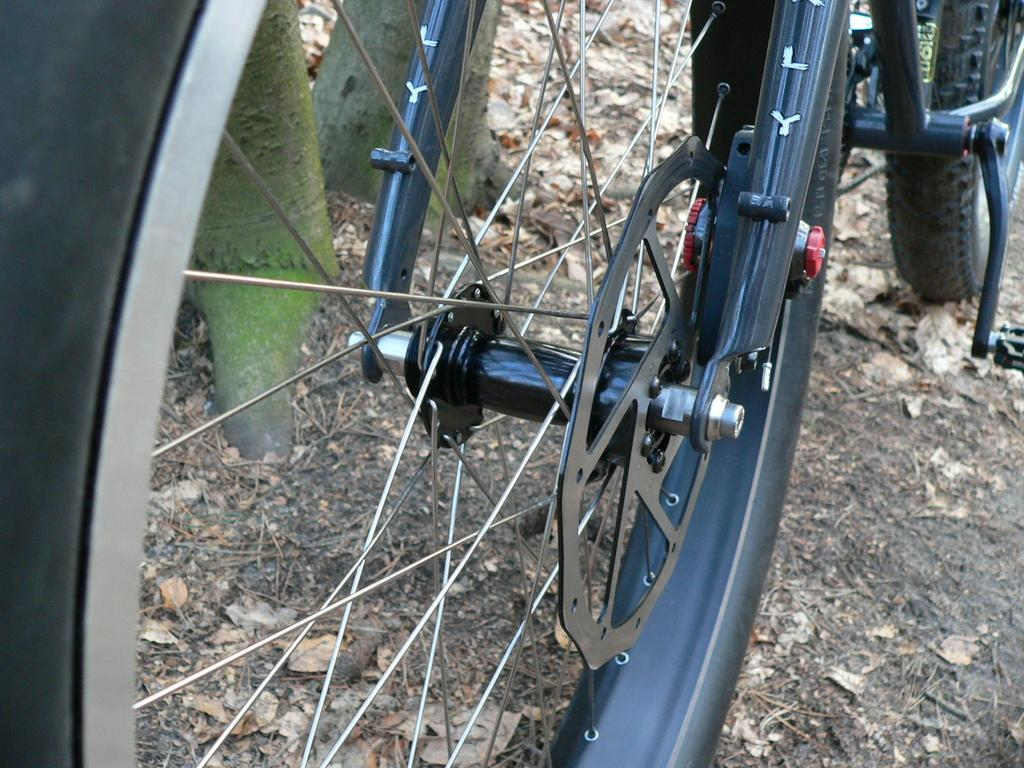What type of vehicle is present in the image? There is a cycle with spokes in the image. What part of the trees can be seen in the image? The barks of trees are visible at the top of the image. What type of stew is being cooked by the person in the image? There is no person present in the image, and therefore no stew is being cooked. What does the image smell like? The image is a visual representation and does not have a smell. 